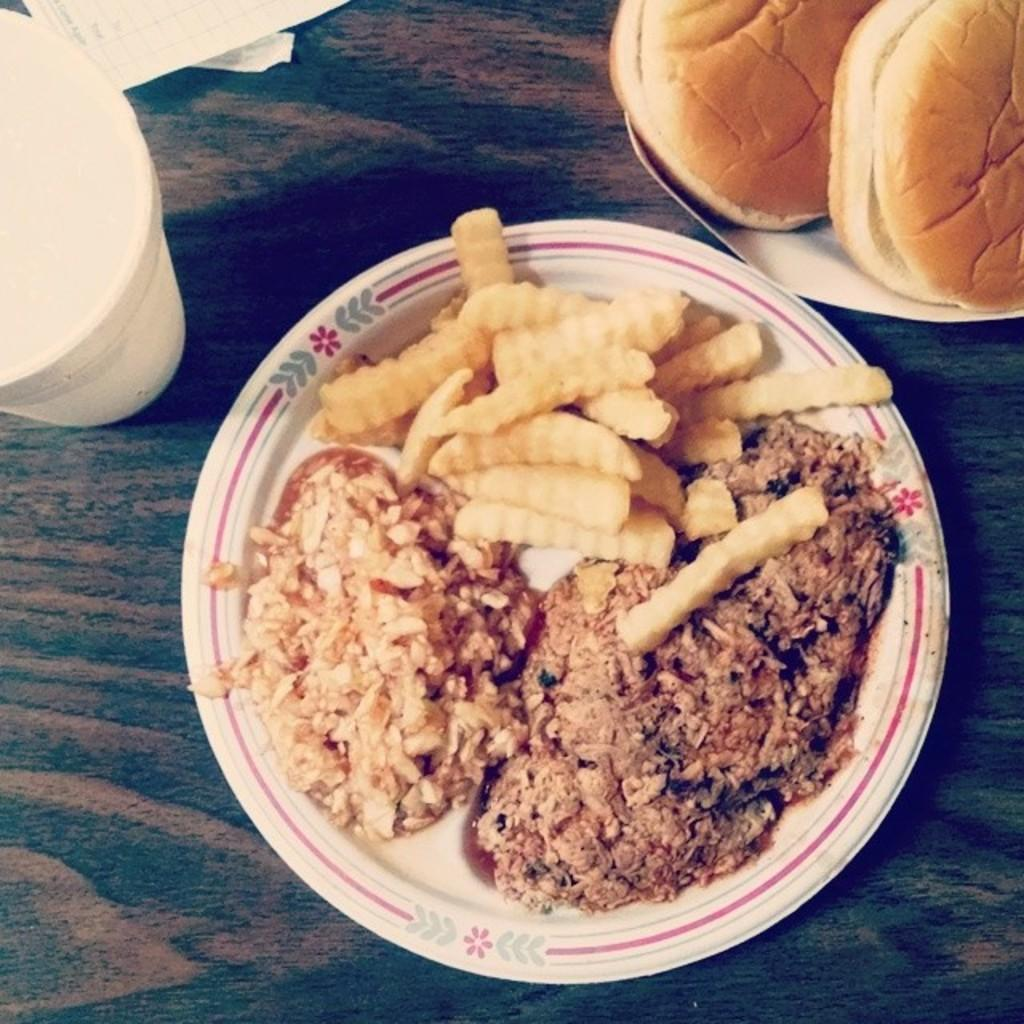What is placed on the platform in the image? There is a cup, a paper, a food item, and two plates on the platform. What is on each of the plates? Each plate contains a braid. What is the food item on the platform? The food item is not specified, but it is on the platform along with the cup, paper, and plates. How many years have passed since the earth was formed in the image? There is no reference to the earth or the formation of the earth in the image, so it is not possible to answer that question. 